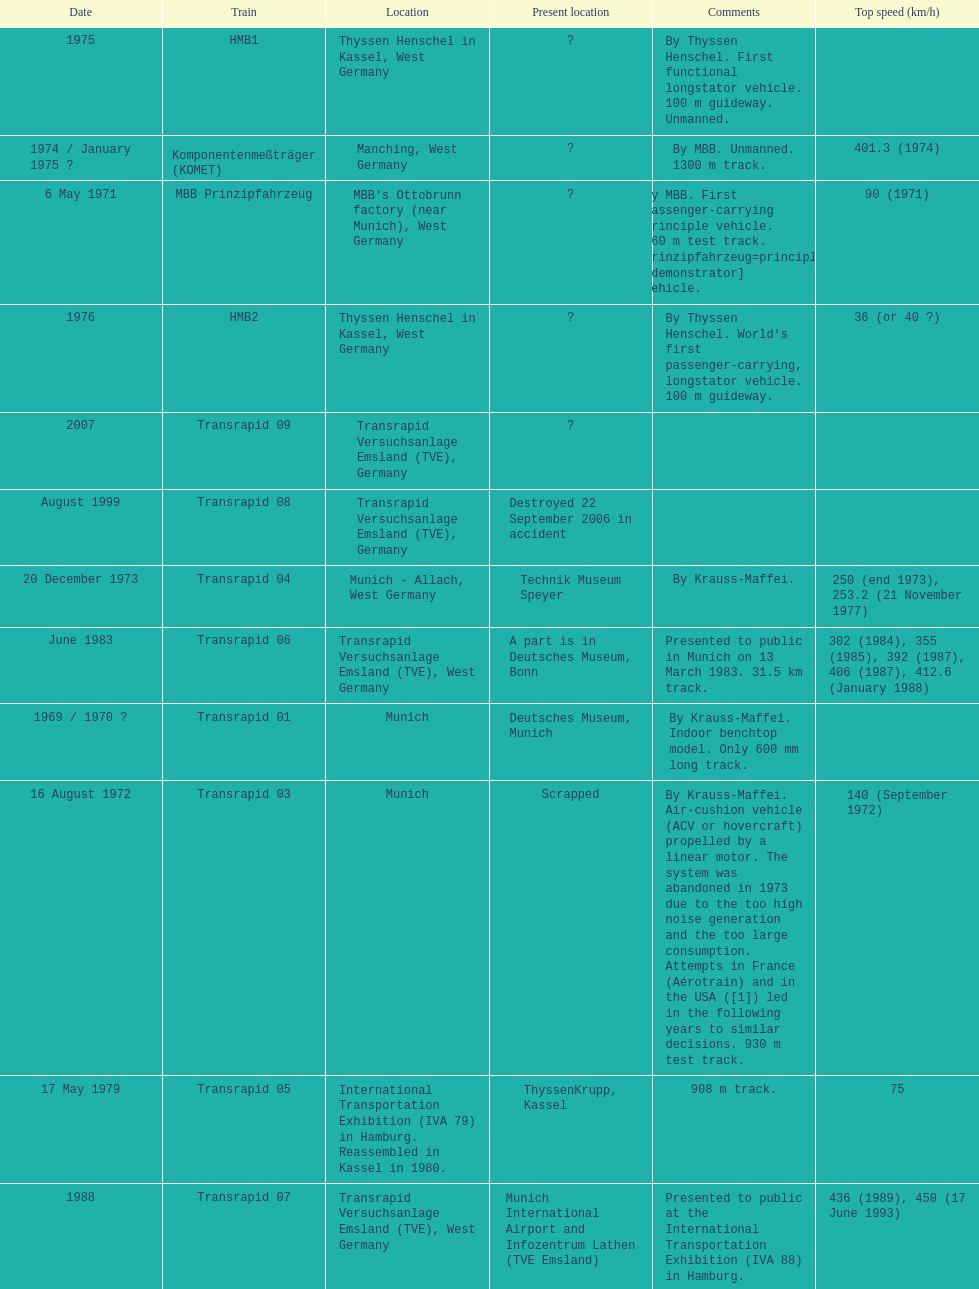Which train has the least top speed? HMB2. Could you parse the entire table? {'header': ['Date', 'Train', 'Location', 'Present location', 'Comments', 'Top speed (km/h)'], 'rows': [['1975', 'HMB1', 'Thyssen Henschel in Kassel, West Germany', '?', 'By Thyssen Henschel. First functional longstator vehicle. 100 m guideway. Unmanned.', ''], ['1974 / January 1975\xa0?', 'Komponentenmeßträger (KOMET)', 'Manching, West Germany', '?', 'By MBB. Unmanned. 1300 m track.', '401.3 (1974)'], ['6 May 1971', 'MBB Prinzipfahrzeug', "MBB's Ottobrunn factory (near Munich), West Germany", '?', 'By MBB. First passenger-carrying principle vehicle. 660 m test track. Prinzipfahrzeug=principle [demonstrator] vehicle.', '90 (1971)'], ['1976', 'HMB2', 'Thyssen Henschel in Kassel, West Germany', '?', "By Thyssen Henschel. World's first passenger-carrying, longstator vehicle. 100 m guideway.", '36 (or 40\xa0?)'], ['2007', 'Transrapid 09', 'Transrapid Versuchsanlage Emsland (TVE), Germany', '?', '', ''], ['August 1999', 'Transrapid 08', 'Transrapid Versuchsanlage Emsland (TVE), Germany', 'Destroyed 22 September 2006 in accident', '', ''], ['20 December 1973', 'Transrapid 04', 'Munich - Allach, West Germany', 'Technik Museum Speyer', 'By Krauss-Maffei.', '250 (end 1973), 253.2 (21 November 1977)'], ['June 1983', 'Transrapid 06', 'Transrapid Versuchsanlage Emsland (TVE), West Germany', 'A part is in Deutsches Museum, Bonn', 'Presented to public in Munich on 13 March 1983. 31.5\xa0km track.', '302 (1984), 355 (1985), 392 (1987), 406 (1987), 412.6 (January 1988)'], ['1969 / 1970\xa0?', 'Transrapid 01', 'Munich', 'Deutsches Museum, Munich', 'By Krauss-Maffei. Indoor benchtop model. Only 600\xa0mm long track.', ''], ['16 August 1972', 'Transrapid 03', 'Munich', 'Scrapped', 'By Krauss-Maffei. Air-cushion vehicle (ACV or hovercraft) propelled by a linear motor. The system was abandoned in 1973 due to the too high noise generation and the too large consumption. Attempts in France (Aérotrain) and in the USA ([1]) led in the following years to similar decisions. 930 m test track.', '140 (September 1972)'], ['17 May 1979', 'Transrapid 05', 'International Transportation Exhibition (IVA 79) in Hamburg. Reassembled in Kassel in 1980.', 'ThyssenKrupp, Kassel', '908 m track.', '75'], ['1988', 'Transrapid 07', 'Transrapid Versuchsanlage Emsland (TVE), West Germany', 'Munich International Airport and Infozentrum Lathen (TVE Emsland)', 'Presented to public at the International Transportation Exhibition (IVA 88) in Hamburg.', '436 (1989), 450 (17 June 1993)'], ['6 October 1971', 'Transrapid 02', "Krauss-Maffei's plant in Munich - Allach, West Germany", 'Krauss-Maffei, Munich', 'By Krauss-Maffei. 930 m test track which included one curve. Displayed at Paris Expo from 4 June to 9 June 1973.', '164 (October 1971)'], ['1972 / 1974\xa0?', 'Erlangener Erprobungsträger (EET 01)', 'Southern edge of Erlangen (near Nuremberg), West Germany', '?', 'By Siemens and others. Electrodynamic suspension (EDS) (like JR-Maglev). Unmanned. 880 m circular track. Erlangener Erprobungsträger=Erlangen test carrier.', '160 / 230 (1974)\xa0?'], ['2002', 'Transrapid SMT', 'Shanghai Maglev Train, China', 'Shanghai, China', '', '501 (12 November 2003)']]} 